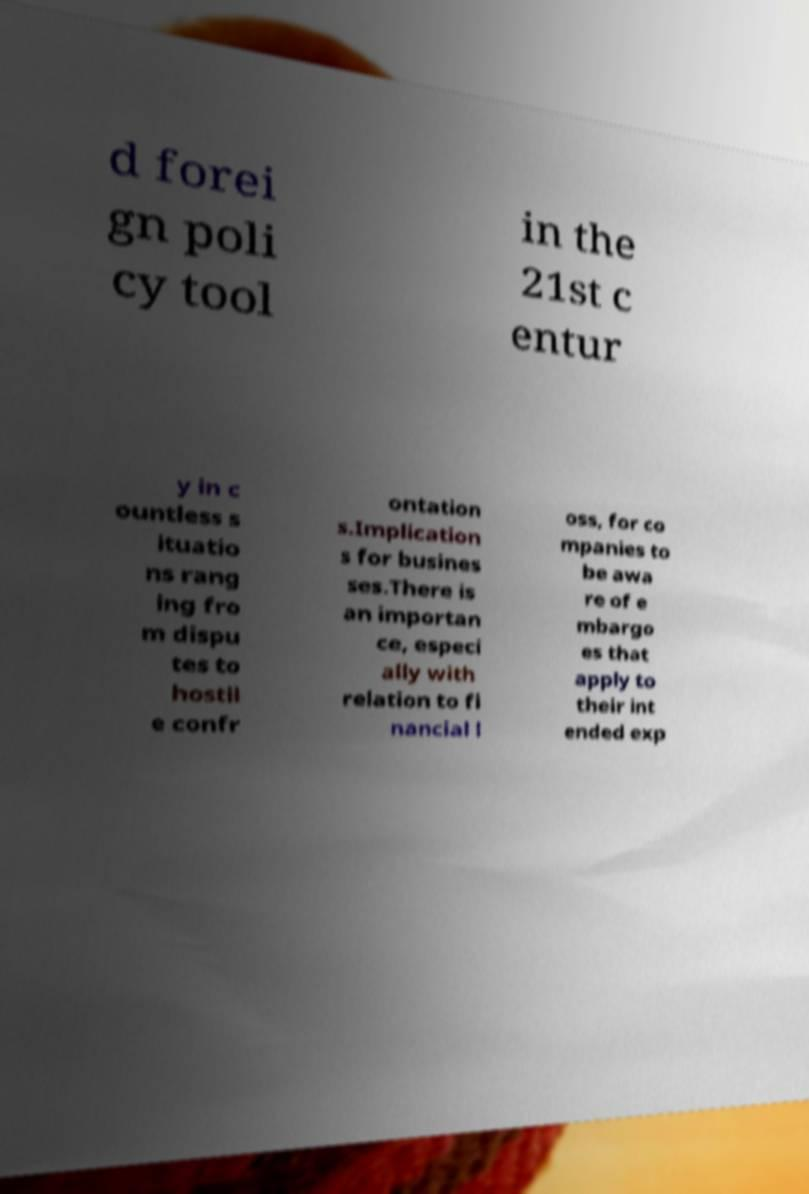What messages or text are displayed in this image? I need them in a readable, typed format. d forei gn poli cy tool in the 21st c entur y in c ountless s ituatio ns rang ing fro m dispu tes to hostil e confr ontation s.Implication s for busines ses.There is an importan ce, especi ally with relation to fi nancial l oss, for co mpanies to be awa re of e mbargo es that apply to their int ended exp 